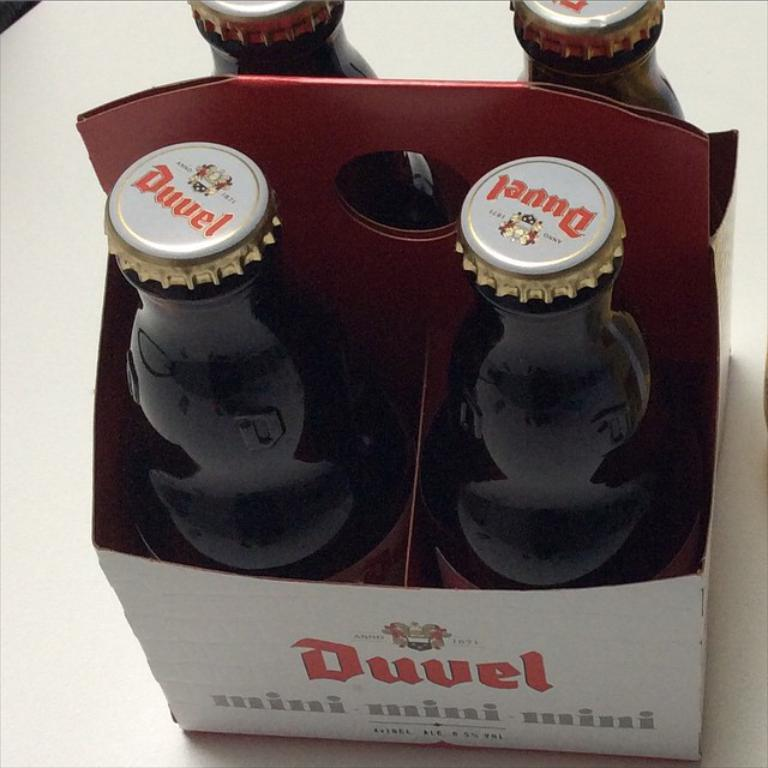What objects can be seen in the image? There are bottles and a box in the image. Can you describe the bottles in the image? The bottles are the main objects visible in the image, but no further details are provided. What else is present in the image besides the bottles? There is a box in the image. Where is the baby sitting in the image? There is no baby present in the image. What type of surprise is hidden in the box in the image? There is no indication of a surprise or any hidden content in the box in the image. 